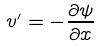Convert formula to latex. <formula><loc_0><loc_0><loc_500><loc_500>v ^ { \prime } = - \frac { \partial \psi } { \partial x }</formula> 